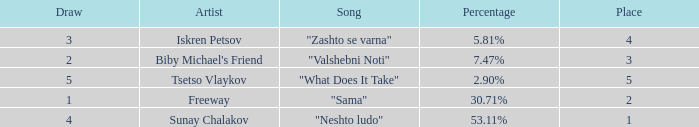What is the highest draw when the place is less than 3 and the percentage is 30.71%? 1.0. Parse the table in full. {'header': ['Draw', 'Artist', 'Song', 'Percentage', 'Place'], 'rows': [['3', 'Iskren Petsov', '"Zashto se varna"', '5.81%', '4'], ['2', "Biby Michael's Friend", '"Valshebni Noti"', '7.47%', '3'], ['5', 'Tsetso Vlaykov', '"What Does It Take"', '2.90%', '5'], ['1', 'Freeway', '"Sama"', '30.71%', '2'], ['4', 'Sunay Chalakov', '"Neshto ludo"', '53.11%', '1']]} 